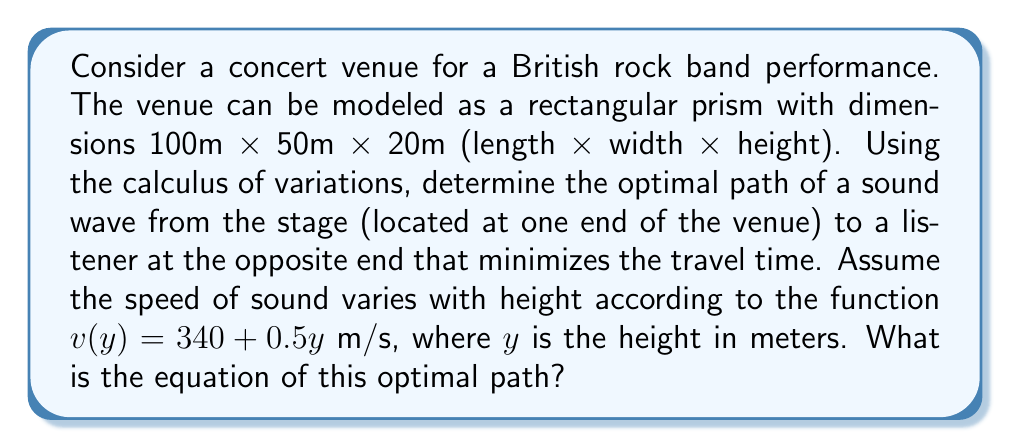Could you help me with this problem? To solve this problem, we'll use the calculus of variations to find the path that minimizes the travel time of the sound wave.

Step 1: Set up the problem
Let the path be described by the function $y(x)$, where $x$ is the horizontal distance from the stage and $y$ is the height.

Step 2: Express the travel time as a functional
The time taken for the sound wave to travel along a small segment of the path is:

$$dt = \frac{ds}{v(y)} = \frac{\sqrt{1 + (y')^2}}{340 + 0.5y} dx$$

The total travel time is the integral:

$$T[y] = \int_0^{100} \frac{\sqrt{1 + (y')^2}}{340 + 0.5y} dx$$

Step 3: Apply the Euler-Lagrange equation
The Euler-Lagrange equation for this problem is:

$$\frac{\partial F}{\partial y} - \frac{d}{dx}\left(\frac{\partial F}{\partial y'}\right) = 0$$

where $F(x,y,y') = \frac{\sqrt{1 + (y')^2}}{340 + 0.5y}$

Step 4: Solve the Euler-Lagrange equation
After applying the Euler-Lagrange equation and simplifying, we get:

$$\frac{d}{dx}\left(\frac{y'}{340 + 0.5y}\right) = \frac{0.5}{(340 + 0.5y)^2}$$

Step 5: Integrate both sides
Integrating both sides with respect to $x$:

$$\frac{y'}{340 + 0.5y} = \frac{1}{340} + C$$

where $C$ is a constant of integration.

Step 6: Solve for $y'$
Rearranging the equation:

$$y' = (340 + 0.5y)\left(\frac{1}{340} + C\right)$$

Step 7: Separate variables and integrate
Separating variables and integrating both sides:

$$\int \frac{dy}{340 + 0.5y} = \int \left(\frac{1}{340} + C\right) dx$$

The solution to this integral is:

$$\frac{2}{0.5} \ln(340 + 0.5y) = \left(\frac{1}{340} + C\right)x + D$$

where $D$ is another constant of integration.

Step 8: Simplify and solve for $y$
Simplifying and solving for $y$:

$$y = \frac{2}{0.5}\left(e^{0.25(\frac{1}{340} + C)x + 0.25D} - 340\right)$$

This is the general equation of the optimal path.
Answer: $y = \frac{2}{0.5}\left(e^{0.25(\frac{1}{340} + C)x + 0.25D} - 340\right)$ 